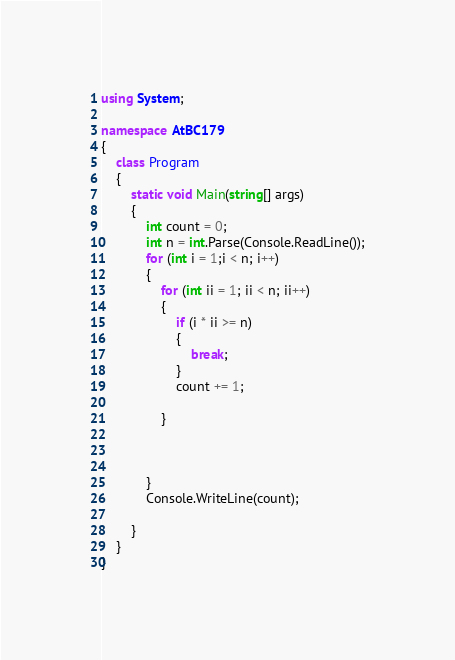<code> <loc_0><loc_0><loc_500><loc_500><_C#_>using System;

namespace AtBC179
{
    class Program
    {
        static void Main(string[] args)
        {
            int count = 0;
            int n = int.Parse(Console.ReadLine());
            for (int i = 1;i < n; i++)
            {
                for (int ii = 1; ii < n; ii++)
                {
                    if (i * ii >= n)
                    {
                        break;
                    }
                    count += 1;

                }

            

            }
            Console.WriteLine(count);
            
        }
    }
}</code> 